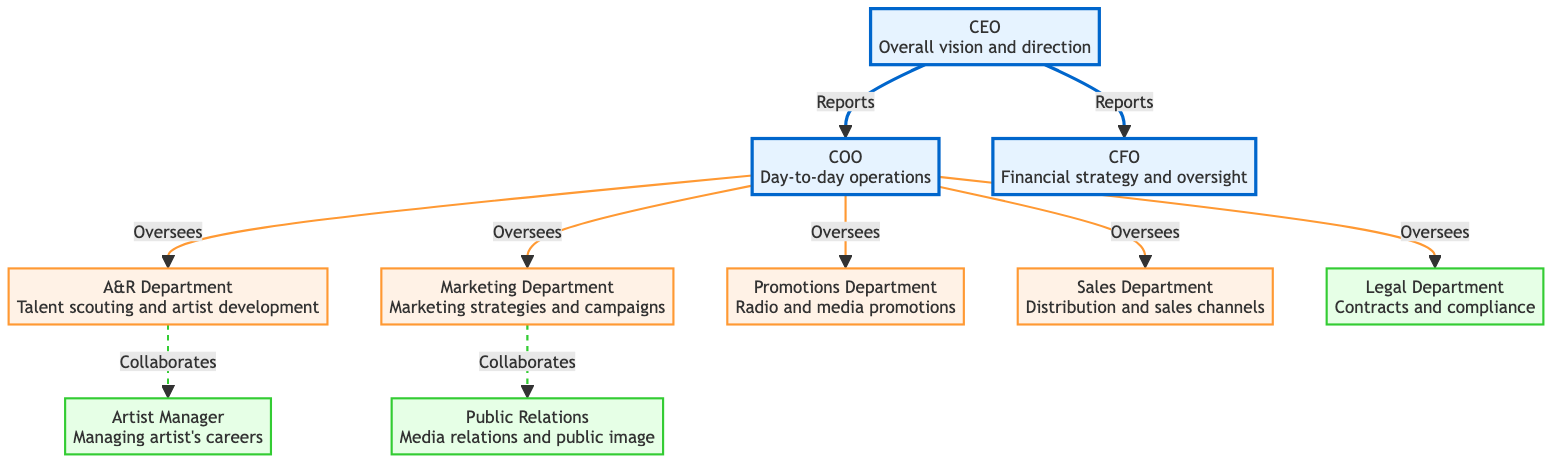What are the main executive roles in the music label? The diagram identifies three main executive roles at the top: CEO, COO, and CFO. Each role has its specific responsibilities listed below.
Answer: CEO, COO, CFO How many departments report to the COO? From the diagram, the COO oversees five departments: A&R, Marketing, Promotions, Sales, and Legal. Therefore, the count is five.
Answer: 5 What role collaborates with the A&R Department? The diagram shows that the Artist Manager collaborates with the A&R Department, indicating a close working relationship for artist development.
Answer: Artist Manager Which department is responsible for financial strategy? According to the diagram, the CFO holds the responsibility for financial strategy and oversight in the music label, as indicated directly under that role.
Answer: CFO What type of relationship exists between Marketing and Public Relations? The diagram illustrates a collaborative relationship between the Marketing Department and Public Relations, as indicated by the dashed line connecting the two.
Answer: Collaborates Which role oversees the Legal Department? The COO is shown as overseeing the Legal Department, establishing the reporting relationship between them in the diagram.
Answer: COO What are the supporting roles depicted in the diagram? The supporting roles are Legal, Artist Manager, and Public Relations, which assist the main departments but do not fall under the main executive hierarchy.
Answer: Legal, Artist Manager, Public Relations Which department is focused on talent scouting? The A&R Department is specifically responsible for talent scouting and artist development, as noted in the diagram.
Answer: A&R Department How many nodes represent external relations roles? The diagram indicates two nodes related to external relations: Public Relations and Promotions, which involve media and public image responsibilities.
Answer: 2 